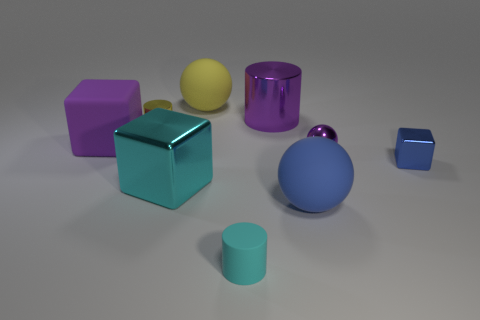Subtract all cubes. How many objects are left? 6 Subtract 0 green spheres. How many objects are left? 9 Subtract all large brown matte balls. Subtract all yellow metallic objects. How many objects are left? 8 Add 3 metal cylinders. How many metal cylinders are left? 5 Add 1 large purple cylinders. How many large purple cylinders exist? 2 